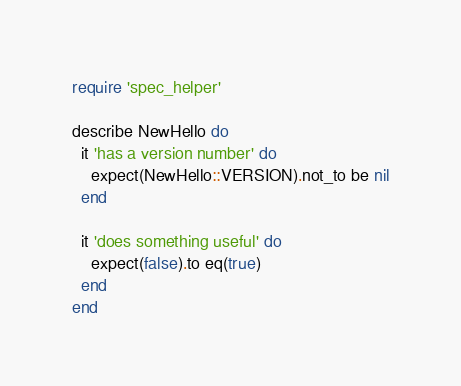<code> <loc_0><loc_0><loc_500><loc_500><_Ruby_>require 'spec_helper'

describe NewHello do
  it 'has a version number' do
    expect(NewHello::VERSION).not_to be nil
  end

  it 'does something useful' do
    expect(false).to eq(true)
  end
end
</code> 